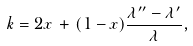Convert formula to latex. <formula><loc_0><loc_0><loc_500><loc_500>k = 2 x \, + \, ( 1 - x ) \frac { \lambda ^ { \prime \prime } - \lambda ^ { \prime } } { \lambda } ,</formula> 